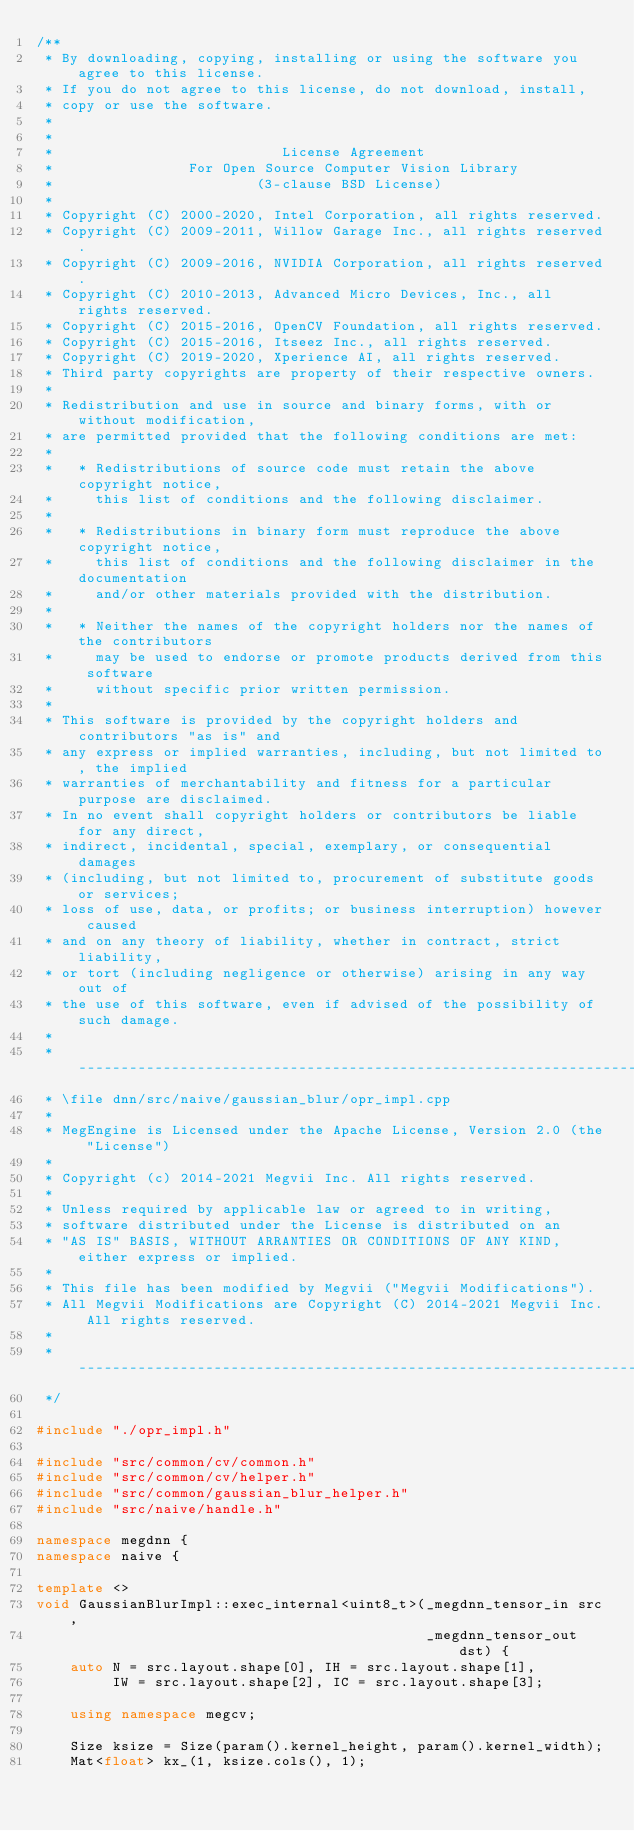Convert code to text. <code><loc_0><loc_0><loc_500><loc_500><_C++_>/**
 * By downloading, copying, installing or using the software you agree to this license.
 * If you do not agree to this license, do not download, install,
 * copy or use the software.
 *
 *
 *                           License Agreement
 *                For Open Source Computer Vision Library
 *                        (3-clause BSD License)
 *
 * Copyright (C) 2000-2020, Intel Corporation, all rights reserved.
 * Copyright (C) 2009-2011, Willow Garage Inc., all rights reserved.
 * Copyright (C) 2009-2016, NVIDIA Corporation, all rights reserved.
 * Copyright (C) 2010-2013, Advanced Micro Devices, Inc., all rights reserved.
 * Copyright (C) 2015-2016, OpenCV Foundation, all rights reserved.
 * Copyright (C) 2015-2016, Itseez Inc., all rights reserved.
 * Copyright (C) 2019-2020, Xperience AI, all rights reserved.
 * Third party copyrights are property of their respective owners.
 *
 * Redistribution and use in source and binary forms, with or without modification,
 * are permitted provided that the following conditions are met:
 *
 *   * Redistributions of source code must retain the above copyright notice,
 *     this list of conditions and the following disclaimer.
 *
 *   * Redistributions in binary form must reproduce the above copyright notice,
 *     this list of conditions and the following disclaimer in the documentation
 *     and/or other materials provided with the distribution.
 *
 *   * Neither the names of the copyright holders nor the names of the contributors
 *     may be used to endorse or promote products derived from this software
 *     without specific prior written permission.
 *
 * This software is provided by the copyright holders and contributors "as is" and
 * any express or implied warranties, including, but not limited to, the implied
 * warranties of merchantability and fitness for a particular purpose are disclaimed.
 * In no event shall copyright holders or contributors be liable for any direct,
 * indirect, incidental, special, exemplary, or consequential damages
 * (including, but not limited to, procurement of substitute goods or services;
 * loss of use, data, or profits; or business interruption) however caused
 * and on any theory of liability, whether in contract, strict liability,
 * or tort (including negligence or otherwise) arising in any way out of
 * the use of this software, even if advised of the possibility of such damage.
 *
 * ---------------------------------------------------------------------------
 * \file dnn/src/naive/gaussian_blur/opr_impl.cpp
 *
 * MegEngine is Licensed under the Apache License, Version 2.0 (the "License")
 *
 * Copyright (c) 2014-2021 Megvii Inc. All rights reserved.
 *
 * Unless required by applicable law or agreed to in writing,
 * software distributed under the License is distributed on an
 * "AS IS" BASIS, WITHOUT ARRANTIES OR CONDITIONS OF ANY KIND, either express or implied.
 *
 * This file has been modified by Megvii ("Megvii Modifications").
 * All Megvii Modifications are Copyright (C) 2014-2021 Megvii Inc. All rights reserved.
 *
 * ---------------------------------------------------------------------------
 */

#include "./opr_impl.h"

#include "src/common/cv/common.h"
#include "src/common/cv/helper.h"
#include "src/common/gaussian_blur_helper.h"
#include "src/naive/handle.h"

namespace megdnn {
namespace naive {

template <>
void GaussianBlurImpl::exec_internal<uint8_t>(_megdnn_tensor_in src,
                                              _megdnn_tensor_out dst) {
    auto N = src.layout.shape[0], IH = src.layout.shape[1],
         IW = src.layout.shape[2], IC = src.layout.shape[3];

    using namespace megcv;

    Size ksize = Size(param().kernel_height, param().kernel_width);
    Mat<float> kx_(1, ksize.cols(), 1);</code> 